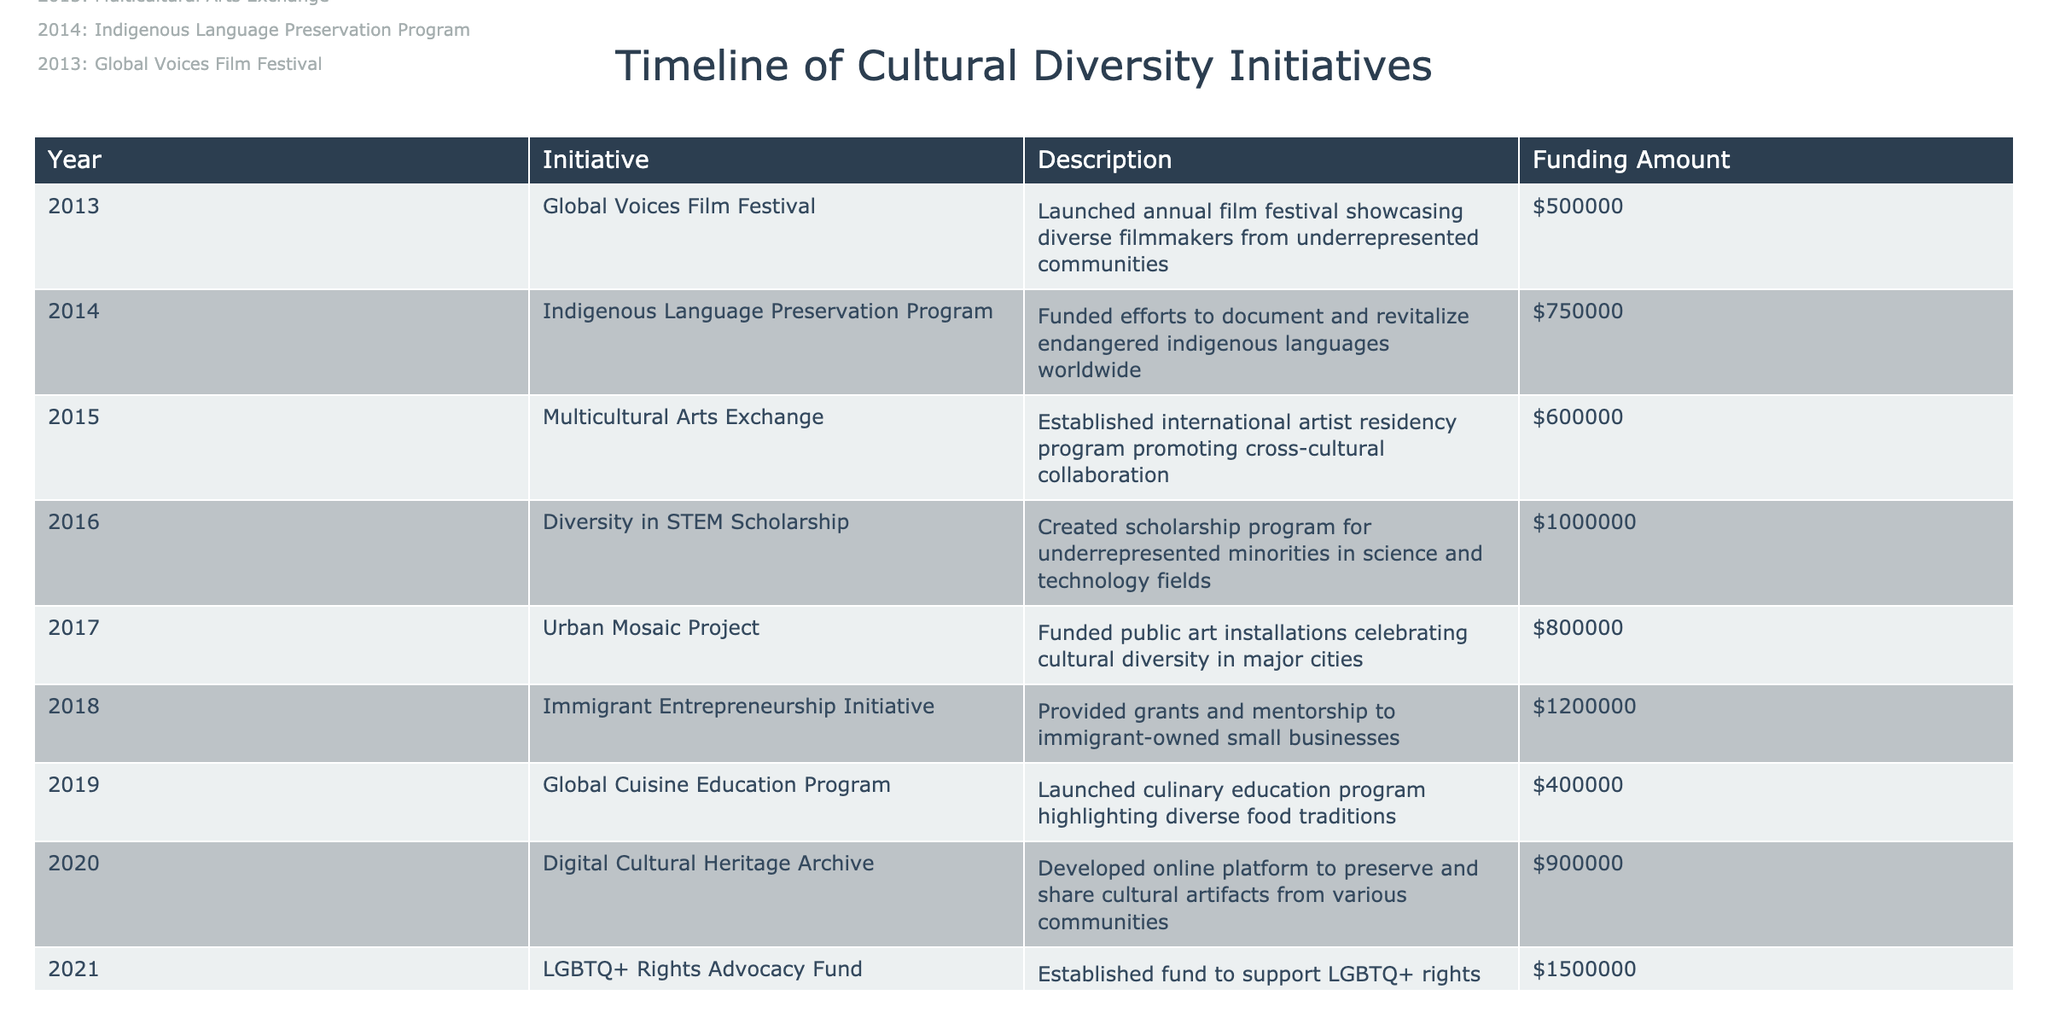What was the total funding amount for initiatives in 2014? From the table, the initiative in 2014 was the Indigenous Language Preservation Program, which had a funding amount of $750,000. There are no other initiatives for that year to consider.
Answer: 750000 Which initiative had the highest funding amount? By examining the funding amounts in the table, the LGBTQ+ Rights Advocacy Fund started in 2021 received the highest funding amount of $1,500,000.
Answer: 1500000 In what year was the Immigrant Entrepreneurship Initiative launched? The table lists the Immigrant Entrepreneurship Initiative under the year 2018. This is a straightforward retrieval question.
Answer: 2018 How much funding was allocated to initiatives in even-numbered years? The initiatives in even-numbered years are from 2014 ($750,000), 2016 ($1,000,000), 2018 ($1,200,000), and 2020 ($900,000). Adding these gives a total of 750000 + 1000000 + 1200000 + 900000 = 3850000.
Answer: 3850000 Was the Global Voices Film Festival funded in 2015? The table indicates that the Global Voices Film Festival was initiated in 2013, not in 2015, thus the statement is false.
Answer: No What is the average funding amount of all initiatives launched prior to 2019? The initiatives prior to 2019 are from 2013 to 2018. Their respective funding amounts are: $500,000 (2013) + $750,000 (2014) + $600,000 (2015) + $1,000,000 (2016) + $800,000 (2017) + $1,200,000 (2018) = $3,850,000. There are six initiatives, so the average is 3850000 / 6 = 641666.67.
Answer: 641666.67 What was the total funding for the initiatives aimed at art and culture? The relevant initiatives are the Global Voices Film Festival ($500,000), the Multicultural Arts Exchange ($600,000), and the Urban Mosaic Project ($800,000). Adding these gives $500,000 + $600,000 + $800,000 = $1,900,000.
Answer: 1900000 Which initiative focused on LGBTQ+ rights and what was its funding? The LGBTQ+ Rights Advocacy Fund, initiated in 2021, focused on LGBTQ+ rights, receiving a funding of $1,500,000.
Answer: LGBTQ+ Rights Advocacy Fund, 1500000 